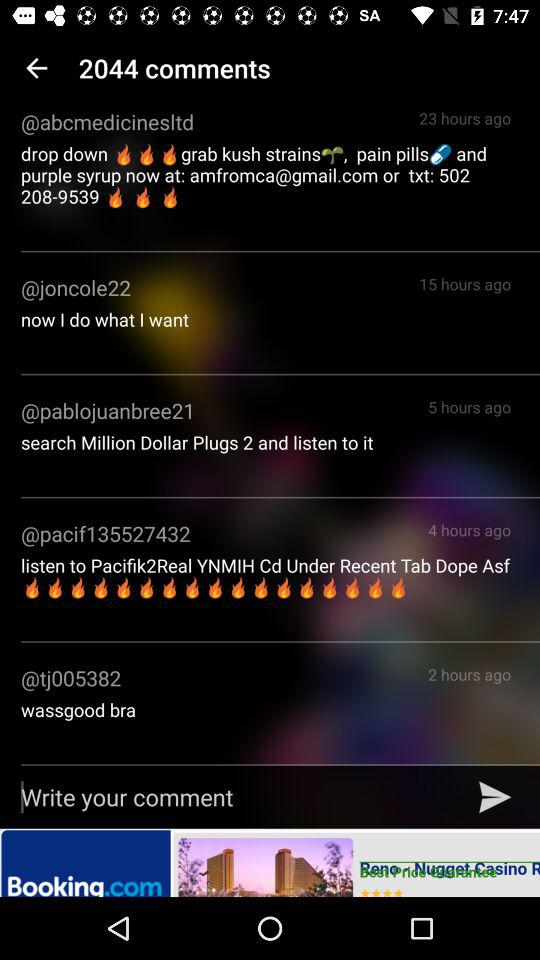How many comments are there? There are 2044 comments. 